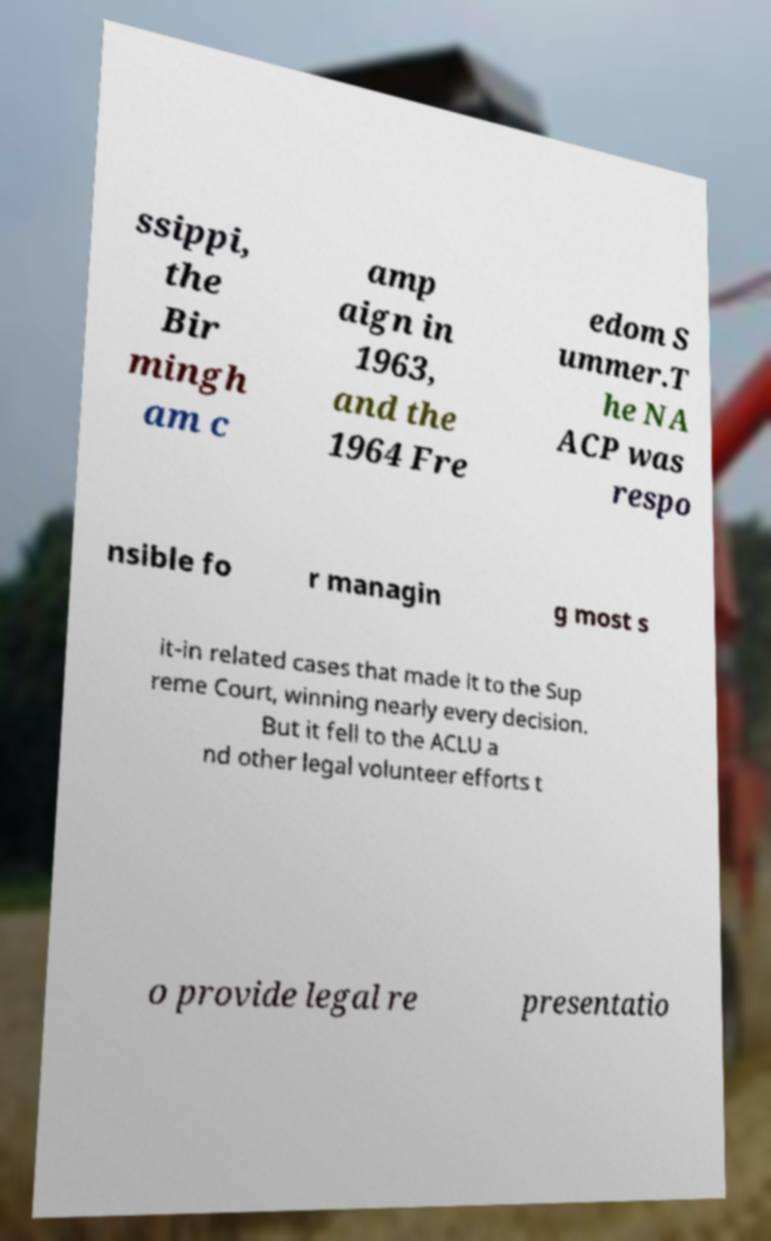Could you extract and type out the text from this image? ssippi, the Bir mingh am c amp aign in 1963, and the 1964 Fre edom S ummer.T he NA ACP was respo nsible fo r managin g most s it-in related cases that made it to the Sup reme Court, winning nearly every decision. But it fell to the ACLU a nd other legal volunteer efforts t o provide legal re presentatio 